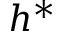Convert formula to latex. <formula><loc_0><loc_0><loc_500><loc_500>h ^ { * }</formula> 